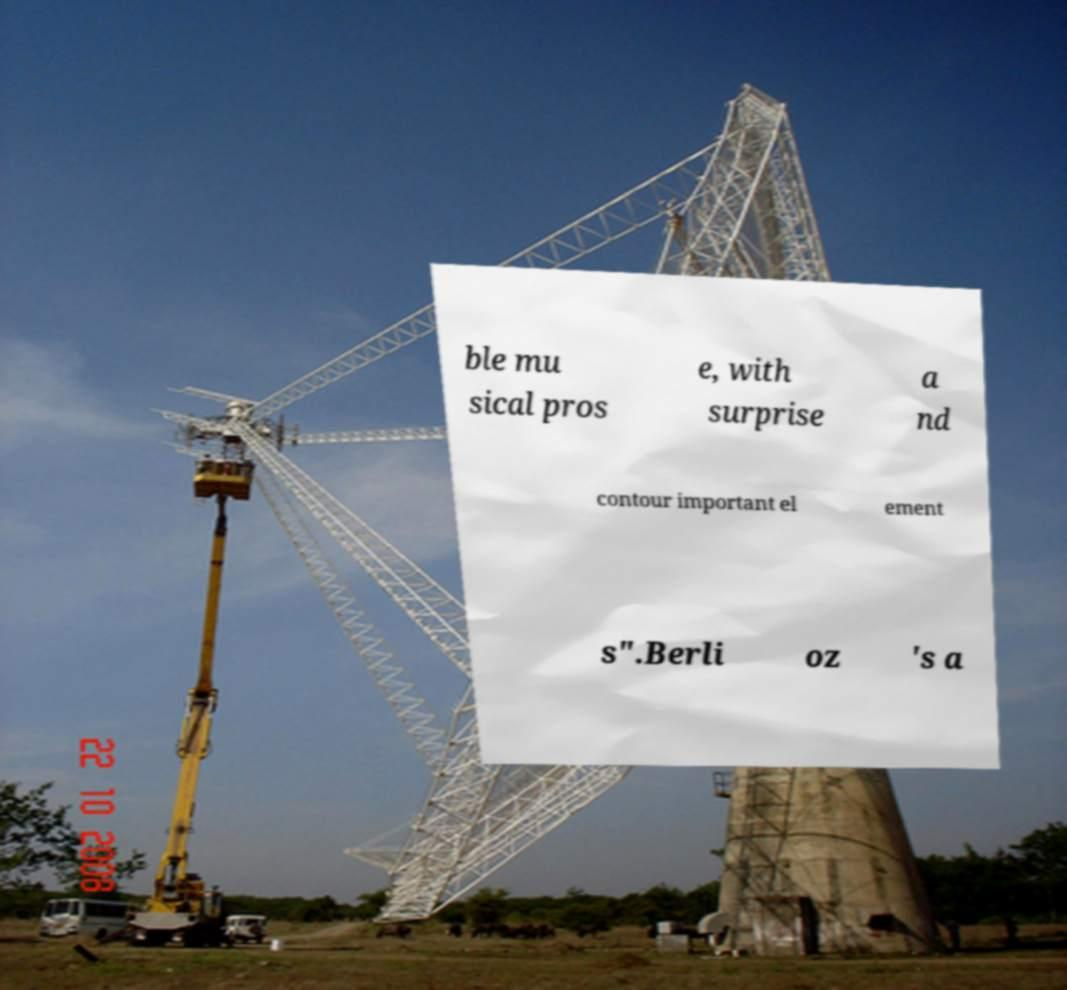Could you extract and type out the text from this image? ble mu sical pros e, with surprise a nd contour important el ement s".Berli oz 's a 